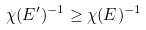Convert formula to latex. <formula><loc_0><loc_0><loc_500><loc_500>\chi ( E ^ { \prime } ) ^ { - 1 } \geq \chi ( E ) ^ { - 1 }</formula> 